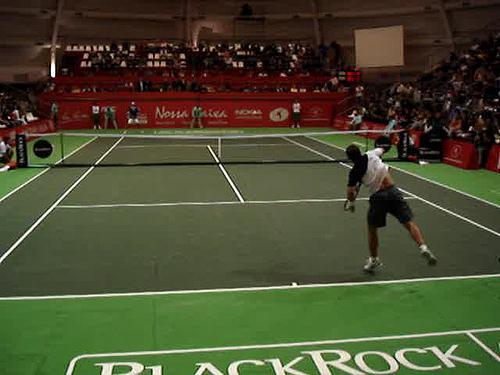Question: how many men playing in the court?
Choices:
A. Four.
B. Eight.
C. Twelve.
D. Two.
Answer with the letter. Answer: D Question: what is the sports the people playing?
Choices:
A. Baseball.
B. Tennis.
C. Basketball.
D. Soccer.
Answer with the letter. Answer: B Question: who are in the court?
Choices:
A. The players.
B. The Judges.
C. The athletes.
D. The team.
Answer with the letter. Answer: A Question: what is the color of the court?
Choices:
A. Brown.
B. Red.
C. Green.
D. Checkered.
Answer with the letter. Answer: C 